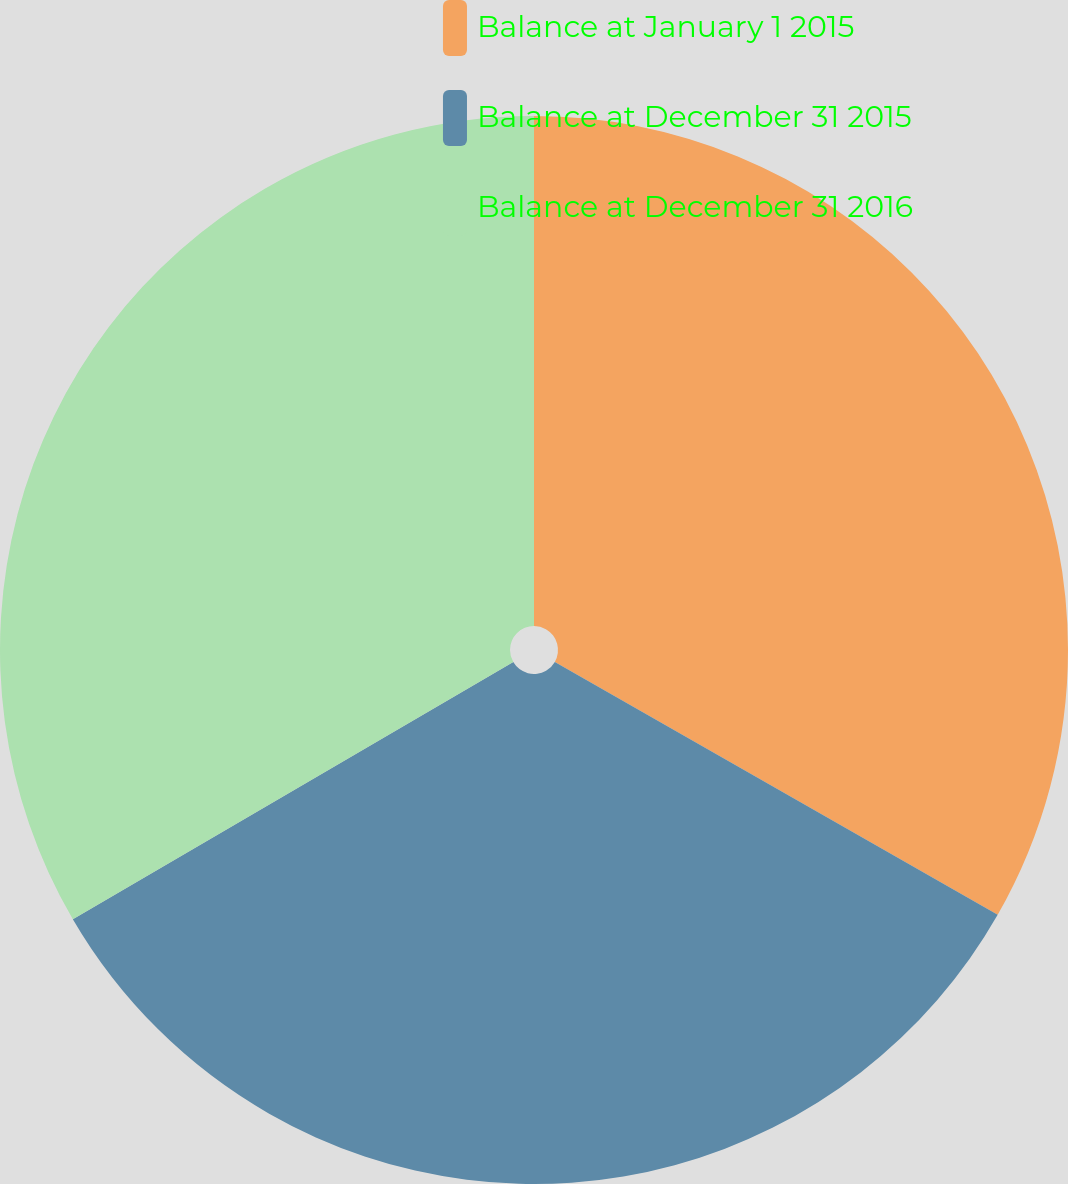Convert chart to OTSL. <chart><loc_0><loc_0><loc_500><loc_500><pie_chart><fcel>Balance at January 1 2015<fcel>Balance at December 31 2015<fcel>Balance at December 31 2016<nl><fcel>33.26%<fcel>33.33%<fcel>33.41%<nl></chart> 